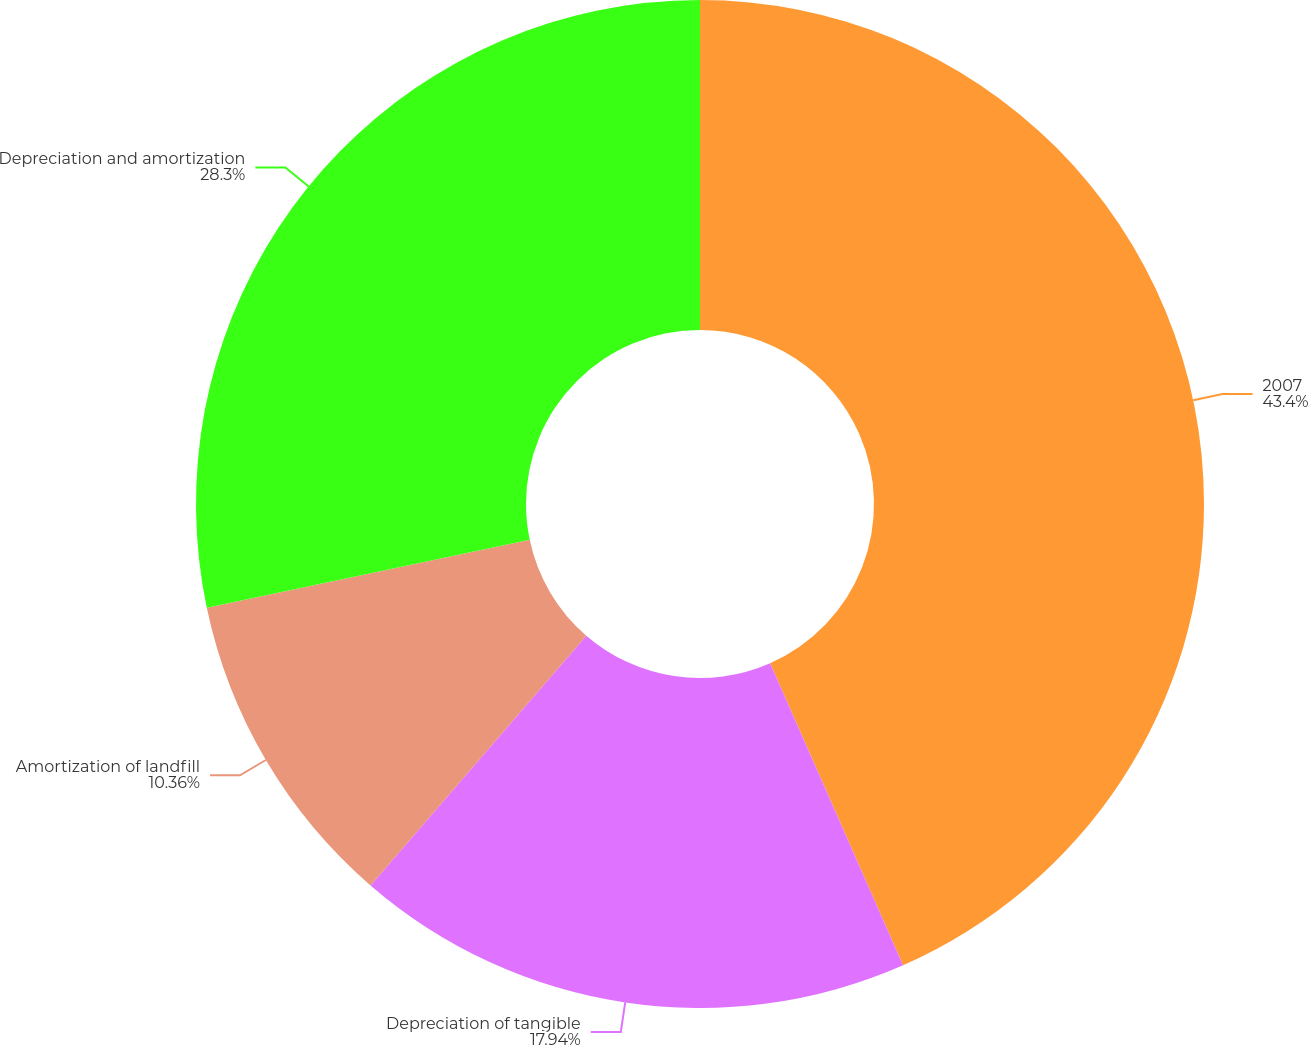<chart> <loc_0><loc_0><loc_500><loc_500><pie_chart><fcel>2007<fcel>Depreciation of tangible<fcel>Amortization of landfill<fcel>Depreciation and amortization<nl><fcel>43.4%<fcel>17.94%<fcel>10.36%<fcel>28.3%<nl></chart> 